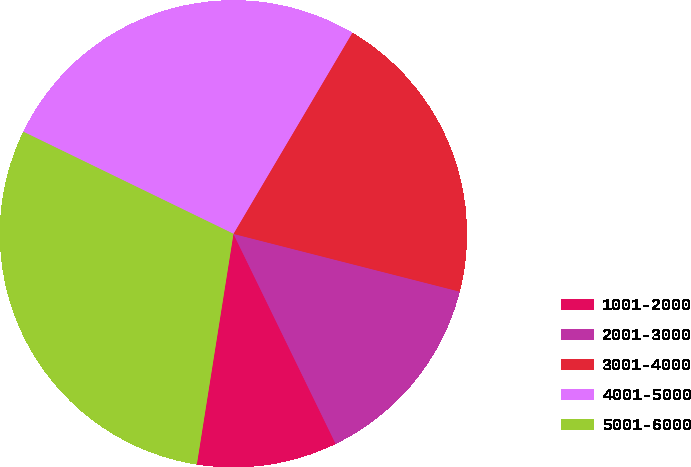Convert chart. <chart><loc_0><loc_0><loc_500><loc_500><pie_chart><fcel>1001-2000<fcel>2001-3000<fcel>3001-4000<fcel>4001-5000<fcel>5001-6000<nl><fcel>9.72%<fcel>13.81%<fcel>20.48%<fcel>26.3%<fcel>29.69%<nl></chart> 